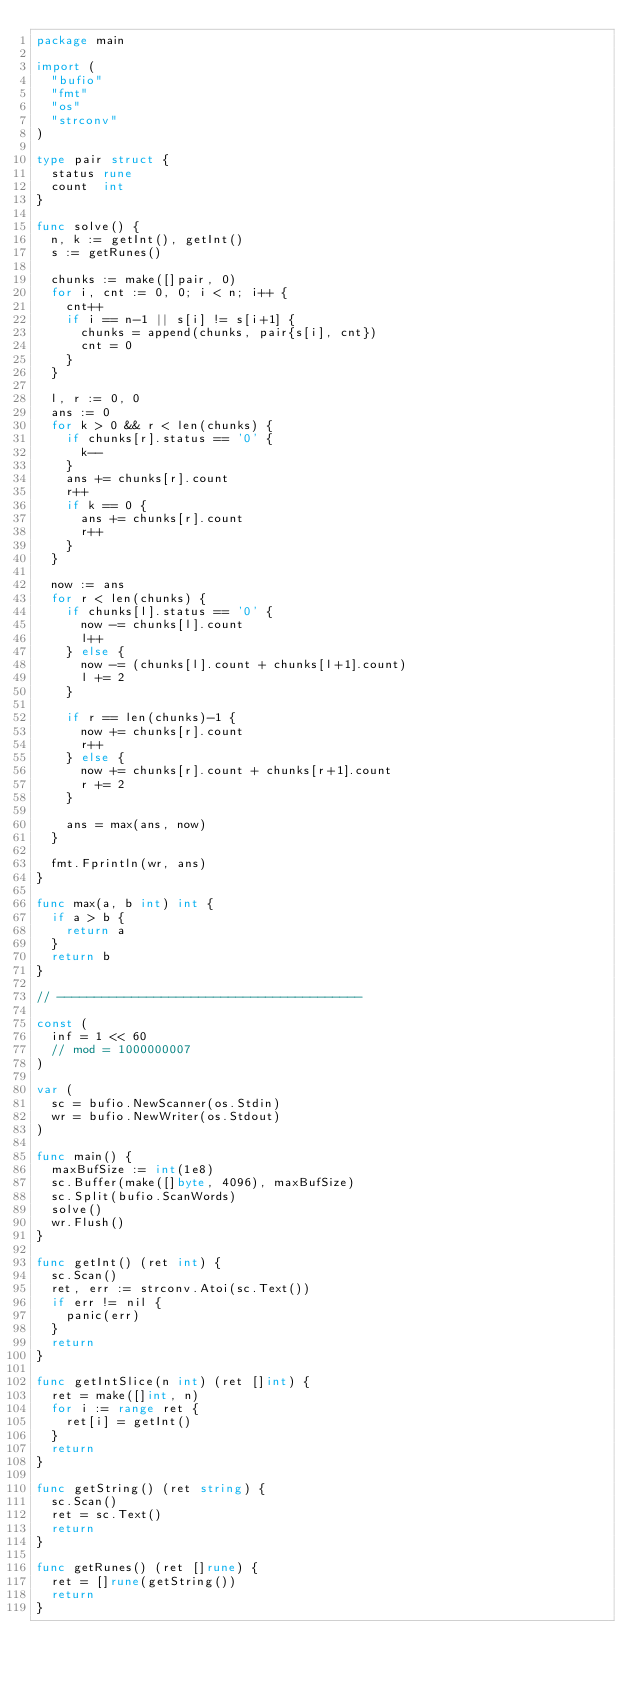<code> <loc_0><loc_0><loc_500><loc_500><_Go_>package main

import (
	"bufio"
	"fmt"
	"os"
	"strconv"
)

type pair struct {
	status rune
	count  int
}

func solve() {
	n, k := getInt(), getInt()
	s := getRunes()

	chunks := make([]pair, 0)
	for i, cnt := 0, 0; i < n; i++ {
		cnt++
		if i == n-1 || s[i] != s[i+1] {
			chunks = append(chunks, pair{s[i], cnt})
			cnt = 0
		}
	}

	l, r := 0, 0
	ans := 0
	for k > 0 && r < len(chunks) {
		if chunks[r].status == '0' {
			k--
		}
		ans += chunks[r].count
		r++
		if k == 0 {
			ans += chunks[r].count
			r++
		}
	}

	now := ans
	for r < len(chunks) {
		if chunks[l].status == '0' {
			now -= chunks[l].count
			l++
		} else {
			now -= (chunks[l].count + chunks[l+1].count)
			l += 2
		}

		if r == len(chunks)-1 {
			now += chunks[r].count
			r++
		} else {
			now += chunks[r].count + chunks[r+1].count
			r += 2
		}

		ans = max(ans, now)
	}

	fmt.Fprintln(wr, ans)
}

func max(a, b int) int {
	if a > b {
		return a
	}
	return b
}

// -----------------------------------------

const (
	inf = 1 << 60
	// mod = 1000000007
)

var (
	sc = bufio.NewScanner(os.Stdin)
	wr = bufio.NewWriter(os.Stdout)
)

func main() {
	maxBufSize := int(1e8)
	sc.Buffer(make([]byte, 4096), maxBufSize)
	sc.Split(bufio.ScanWords)
	solve()
	wr.Flush()
}

func getInt() (ret int) {
	sc.Scan()
	ret, err := strconv.Atoi(sc.Text())
	if err != nil {
		panic(err)
	}
	return
}

func getIntSlice(n int) (ret []int) {
	ret = make([]int, n)
	for i := range ret {
		ret[i] = getInt()
	}
	return
}

func getString() (ret string) {
	sc.Scan()
	ret = sc.Text()
	return
}

func getRunes() (ret []rune) {
	ret = []rune(getString())
	return
}
</code> 